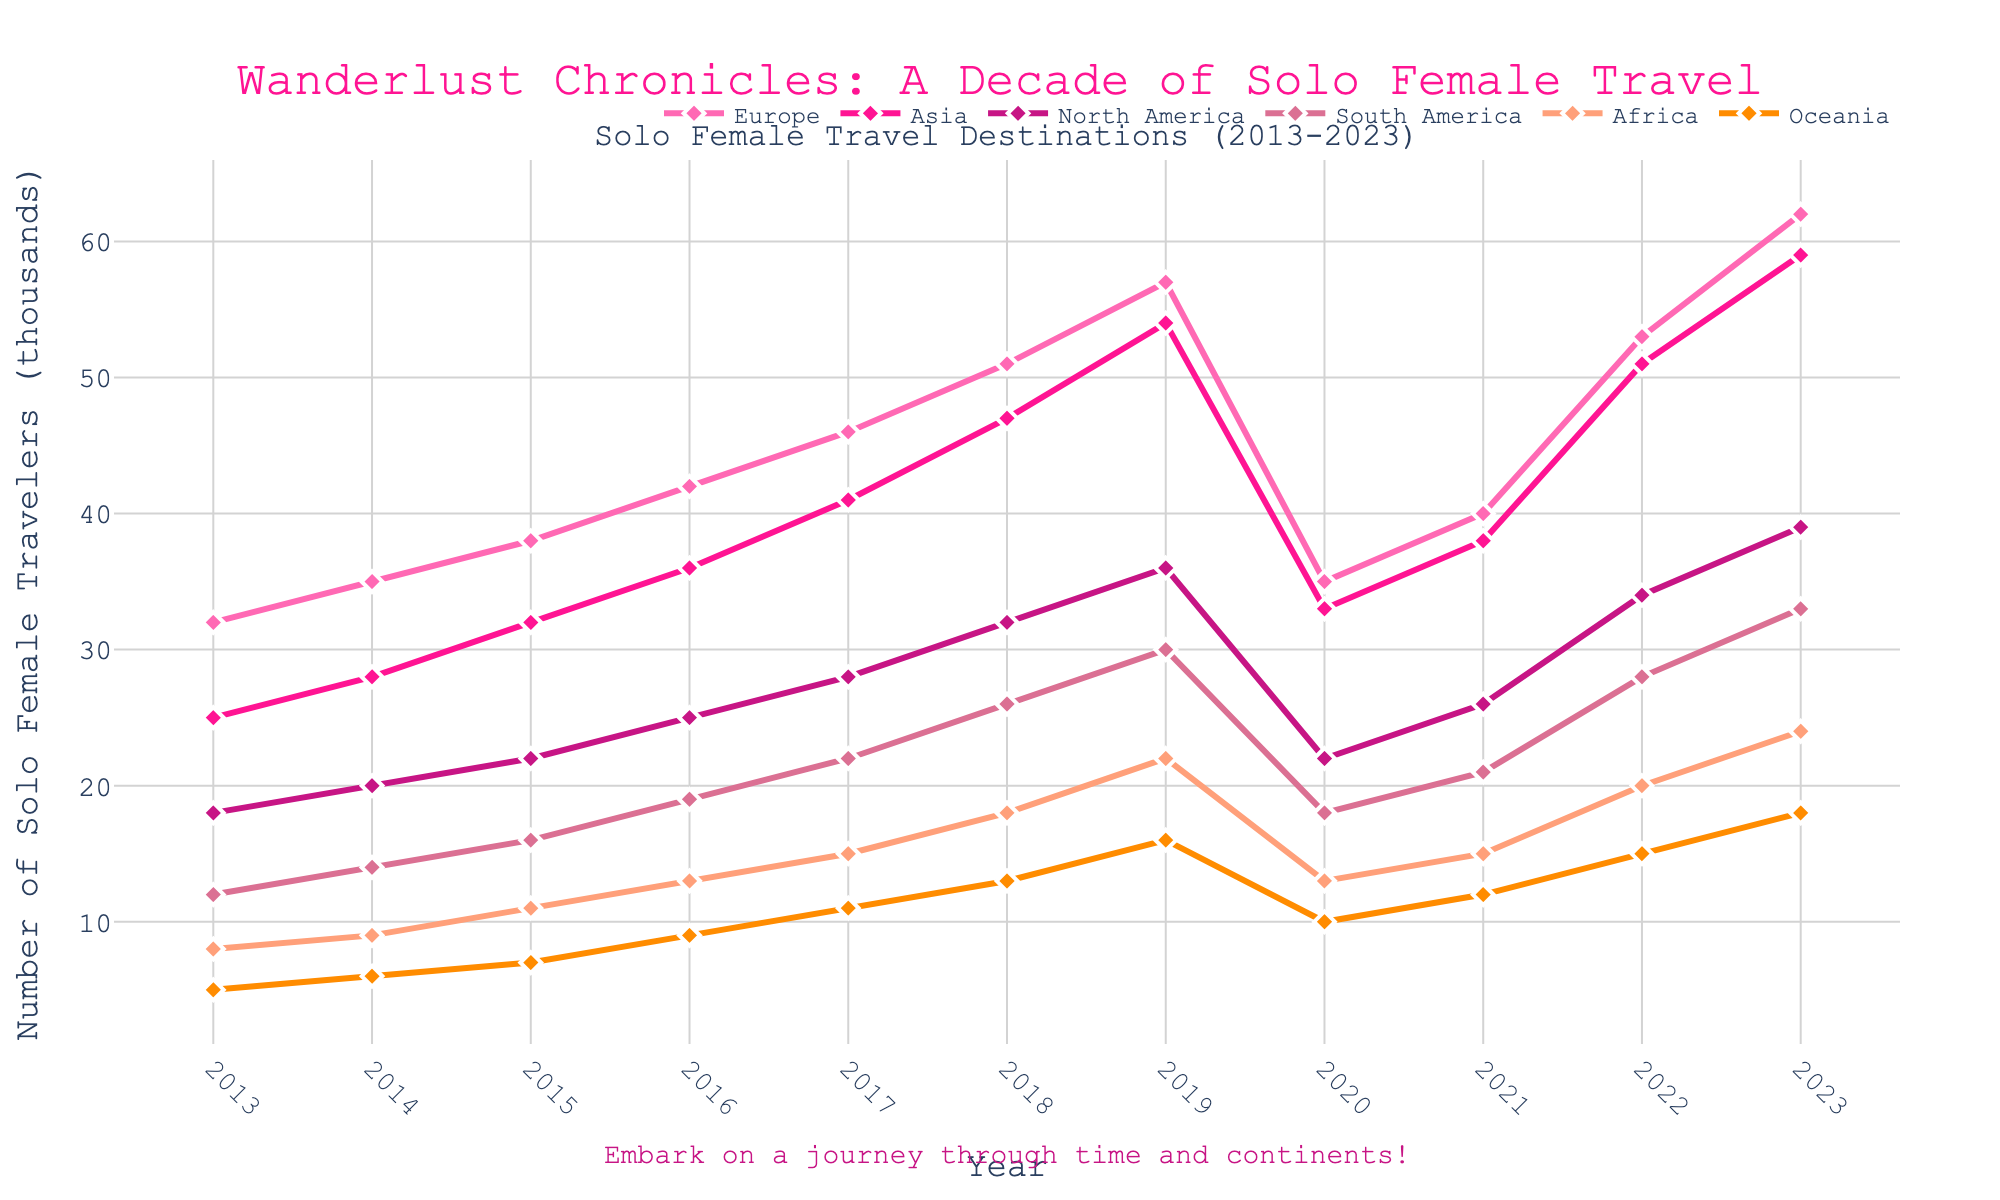Which continent had the highest number of solo female travelers in 2019? In the figure for 2019, the line representing Europe is the highest. This indicates that Europe had the highest number of solo female travelers in that year.
Answer: Europe How did the number of solo female travelers to Asia change from 2020 to 2021? Comparing the values for Asia in 2020 and 2021, we see that the number increased from 33 to 38.
Answer: It increased What is the combined number of solo female travelers to North America and South America in 2018? In 2018, North America had 32 thousand and South America had 26 thousand solo female travelers. Adding these gives 32 + 26 = 58.
Answer: 58 Which continent shows the most significant increase in solo female travelers between 2019 and 2023? Checking the values, Europe rose from 57 to 62, Asia from 54 to 59. Europe had a 5-thousand increase and Asia also had a 5-thousand increase. But we need to check their relative difference: (62-57)/57 = 0.0877 and (59-54)/54 = 0.0926. The relative percentage increase of Asia is higher.
Answer: Asia What is the average number of solo female travelers to Oceania from 2013 to 2023? Sum the values for Oceania from 2013 to 2023: (5 + 6 + 7 + 9 + 11 + 13 + 16 + 10 + 12 + 15 + 18) = 122. Divide by 11 (the number of years): 122/11 ≈ 11.09.
Answer: Approximately 11.09 In which year did Europe see the largest single-year decrease in travelers? From 2019 to 2020, Europe decreased from 57 to 35 which is a reduction of 22 thousand. This is the largest single-year decrease.
Answer: 2020 Which continents had a consistent increase in the number of solo female travelers from 2013 to 2017? Reviewing the chart, both Europe and Asia show a consistent year-over-year increase from 2013 to 2017, without any dips.
Answer: Europe and Asia How does the 2023 value for Africa compare to its 2013 value? In 2023, Africa had 24 thousand travelers, and in 2013, it had 8 thousand. The difference is 24 - 8 = 16 thousand. So, it is three times greater.
Answer: 3 times greater 